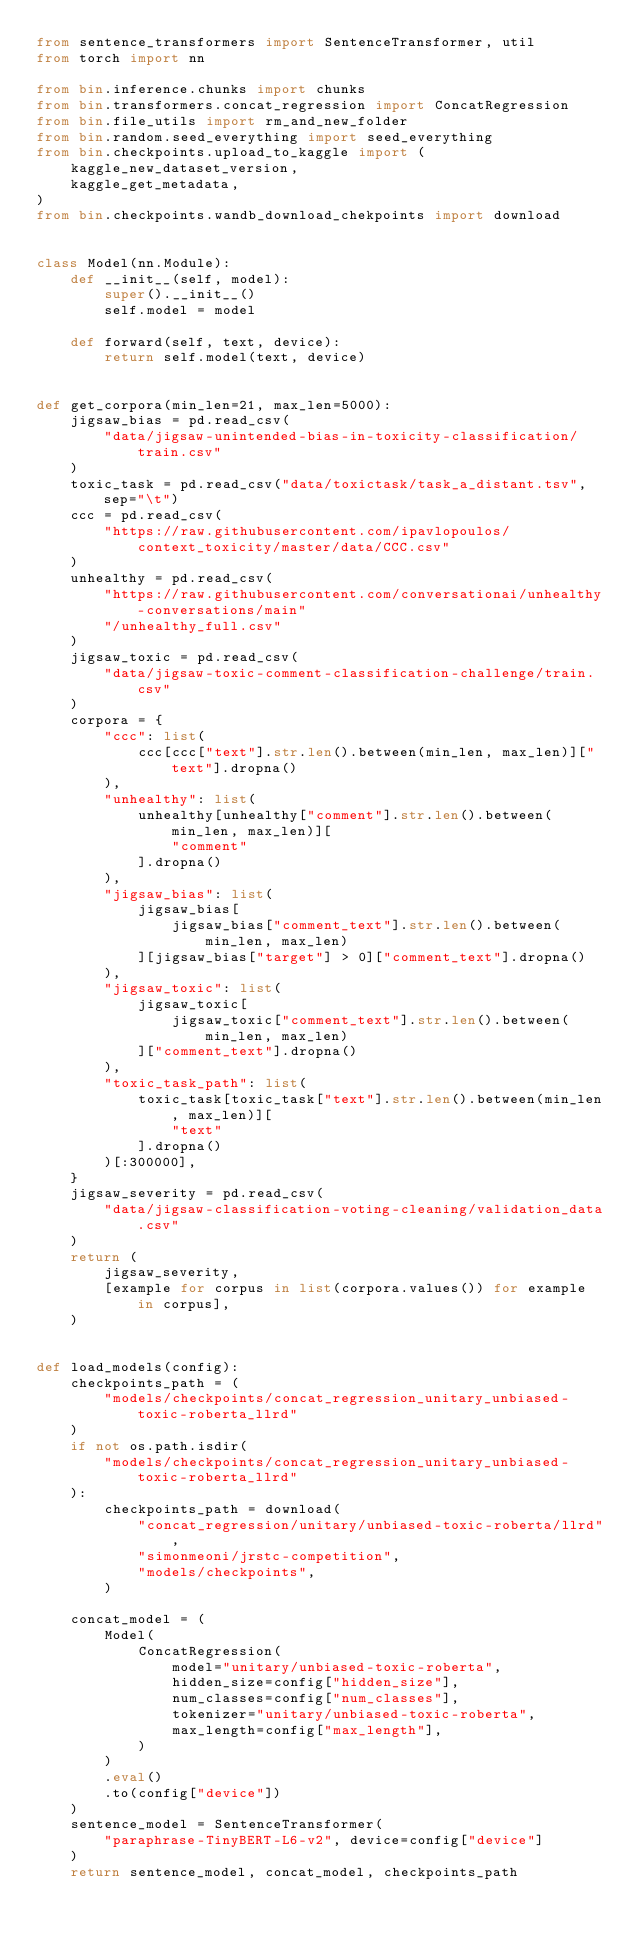<code> <loc_0><loc_0><loc_500><loc_500><_Python_>from sentence_transformers import SentenceTransformer, util
from torch import nn

from bin.inference.chunks import chunks
from bin.transformers.concat_regression import ConcatRegression
from bin.file_utils import rm_and_new_folder
from bin.random.seed_everything import seed_everything
from bin.checkpoints.upload_to_kaggle import (
    kaggle_new_dataset_version,
    kaggle_get_metadata,
)
from bin.checkpoints.wandb_download_chekpoints import download


class Model(nn.Module):
    def __init__(self, model):
        super().__init__()
        self.model = model

    def forward(self, text, device):
        return self.model(text, device)


def get_corpora(min_len=21, max_len=5000):
    jigsaw_bias = pd.read_csv(
        "data/jigsaw-unintended-bias-in-toxicity-classification/train.csv"
    )
    toxic_task = pd.read_csv("data/toxictask/task_a_distant.tsv", sep="\t")
    ccc = pd.read_csv(
        "https://raw.githubusercontent.com/ipavlopoulos/context_toxicity/master/data/CCC.csv"
    )
    unhealthy = pd.read_csv(
        "https://raw.githubusercontent.com/conversationai/unhealthy-conversations/main"
        "/unhealthy_full.csv"
    )
    jigsaw_toxic = pd.read_csv(
        "data/jigsaw-toxic-comment-classification-challenge/train.csv"
    )
    corpora = {
        "ccc": list(
            ccc[ccc["text"].str.len().between(min_len, max_len)]["text"].dropna()
        ),
        "unhealthy": list(
            unhealthy[unhealthy["comment"].str.len().between(min_len, max_len)][
                "comment"
            ].dropna()
        ),
        "jigsaw_bias": list(
            jigsaw_bias[
                jigsaw_bias["comment_text"].str.len().between(min_len, max_len)
            ][jigsaw_bias["target"] > 0]["comment_text"].dropna()
        ),
        "jigsaw_toxic": list(
            jigsaw_toxic[
                jigsaw_toxic["comment_text"].str.len().between(min_len, max_len)
            ]["comment_text"].dropna()
        ),
        "toxic_task_path": list(
            toxic_task[toxic_task["text"].str.len().between(min_len, max_len)][
                "text"
            ].dropna()
        )[:300000],
    }
    jigsaw_severity = pd.read_csv(
        "data/jigsaw-classification-voting-cleaning/validation_data.csv"
    )
    return (
        jigsaw_severity,
        [example for corpus in list(corpora.values()) for example in corpus],
    )


def load_models(config):
    checkpoints_path = (
        "models/checkpoints/concat_regression_unitary_unbiased-toxic-roberta_llrd"
    )
    if not os.path.isdir(
        "models/checkpoints/concat_regression_unitary_unbiased-toxic-roberta_llrd"
    ):
        checkpoints_path = download(
            "concat_regression/unitary/unbiased-toxic-roberta/llrd",
            "simonmeoni/jrstc-competition",
            "models/checkpoints",
        )

    concat_model = (
        Model(
            ConcatRegression(
                model="unitary/unbiased-toxic-roberta",
                hidden_size=config["hidden_size"],
                num_classes=config["num_classes"],
                tokenizer="unitary/unbiased-toxic-roberta",
                max_length=config["max_length"],
            )
        )
        .eval()
        .to(config["device"])
    )
    sentence_model = SentenceTransformer(
        "paraphrase-TinyBERT-L6-v2", device=config["device"]
    )
    return sentence_model, concat_model, checkpoints_path

</code> 